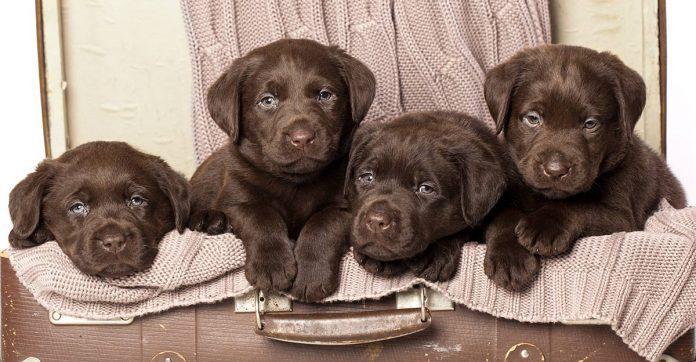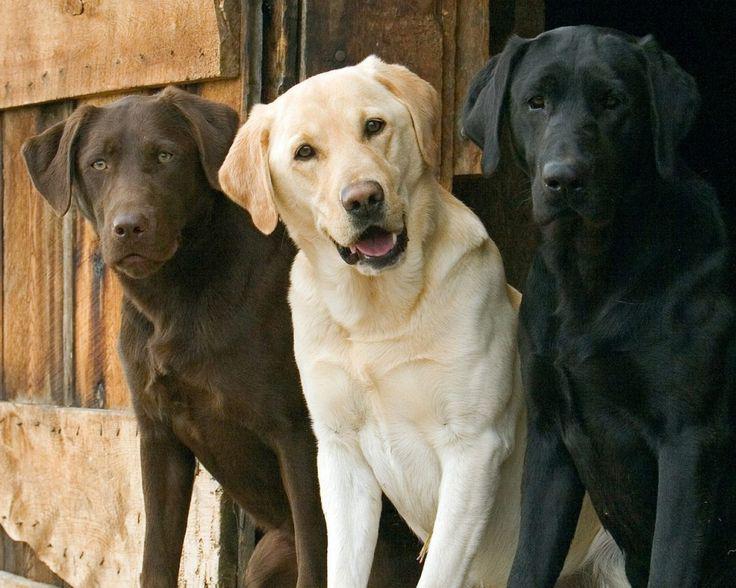The first image is the image on the left, the second image is the image on the right. For the images displayed, is the sentence "One image shows exactly two adult dogs, and the other image shows a row of at least three puppies sitting upright." factually correct? Answer yes or no. No. The first image is the image on the left, the second image is the image on the right. Considering the images on both sides, is "There are more dogs in the image on the left." valid? Answer yes or no. Yes. 